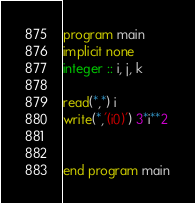Convert code to text. <code><loc_0><loc_0><loc_500><loc_500><_FORTRAN_>program main
implicit none
integer :: i, j, k

read(*,*) i
write(*,'(i0)') 3*i**2


end program main
</code> 